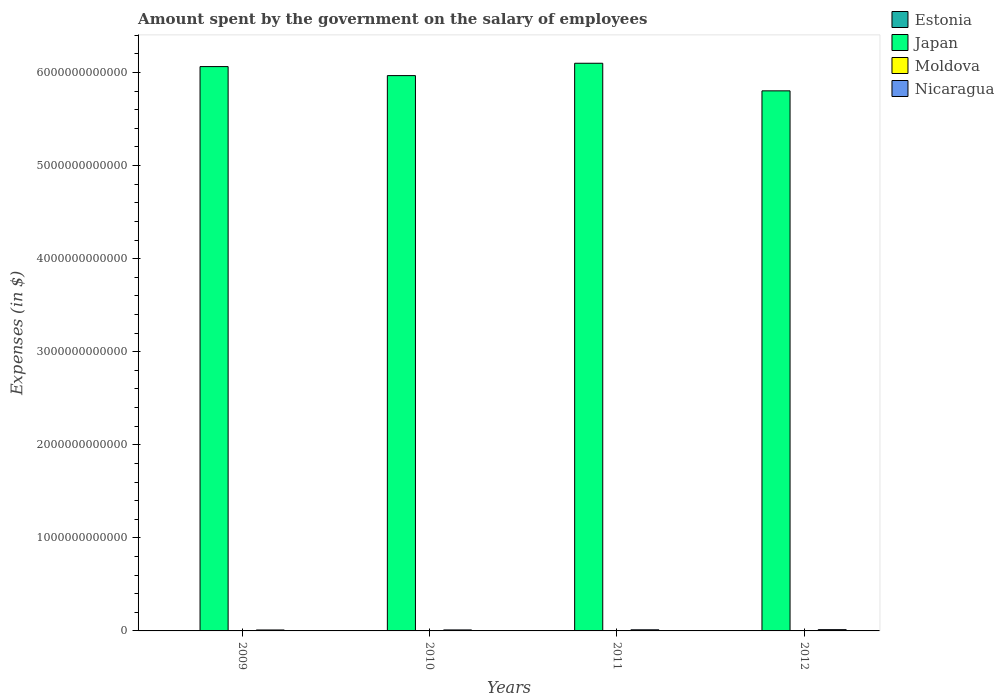How many different coloured bars are there?
Keep it short and to the point. 4. Are the number of bars on each tick of the X-axis equal?
Provide a short and direct response. Yes. How many bars are there on the 4th tick from the left?
Offer a very short reply. 4. How many bars are there on the 2nd tick from the right?
Provide a succinct answer. 4. What is the label of the 4th group of bars from the left?
Your answer should be very brief. 2012. In how many cases, is the number of bars for a given year not equal to the number of legend labels?
Keep it short and to the point. 0. What is the amount spent on the salary of employees by the government in Nicaragua in 2010?
Make the answer very short. 1.07e+1. Across all years, what is the maximum amount spent on the salary of employees by the government in Nicaragua?
Give a very brief answer. 1.36e+1. Across all years, what is the minimum amount spent on the salary of employees by the government in Nicaragua?
Give a very brief answer. 1.02e+1. What is the total amount spent on the salary of employees by the government in Nicaragua in the graph?
Your response must be concise. 4.64e+1. What is the difference between the amount spent on the salary of employees by the government in Japan in 2009 and that in 2010?
Provide a short and direct response. 9.68e+1. What is the difference between the amount spent on the salary of employees by the government in Estonia in 2010 and the amount spent on the salary of employees by the government in Nicaragua in 2009?
Offer a very short reply. -9.13e+09. What is the average amount spent on the salary of employees by the government in Estonia per year?
Provide a succinct answer. 1.09e+09. In the year 2009, what is the difference between the amount spent on the salary of employees by the government in Japan and amount spent on the salary of employees by the government in Estonia?
Provide a short and direct response. 6.06e+12. What is the ratio of the amount spent on the salary of employees by the government in Japan in 2009 to that in 2011?
Offer a terse response. 0.99. Is the amount spent on the salary of employees by the government in Estonia in 2011 less than that in 2012?
Give a very brief answer. Yes. What is the difference between the highest and the second highest amount spent on the salary of employees by the government in Japan?
Your answer should be very brief. 3.58e+1. What is the difference between the highest and the lowest amount spent on the salary of employees by the government in Moldova?
Your answer should be very brief. 4.85e+08. What does the 4th bar from the left in 2011 represents?
Make the answer very short. Nicaragua. How many years are there in the graph?
Your answer should be compact. 4. What is the difference between two consecutive major ticks on the Y-axis?
Your response must be concise. 1.00e+12. Does the graph contain any zero values?
Your answer should be very brief. No. How many legend labels are there?
Your response must be concise. 4. What is the title of the graph?
Provide a short and direct response. Amount spent by the government on the salary of employees. What is the label or title of the X-axis?
Offer a terse response. Years. What is the label or title of the Y-axis?
Offer a very short reply. Expenses (in $). What is the Expenses (in $) of Estonia in 2009?
Your response must be concise. 1.07e+09. What is the Expenses (in $) in Japan in 2009?
Provide a short and direct response. 6.06e+12. What is the Expenses (in $) of Moldova in 2009?
Your answer should be very brief. 3.47e+09. What is the Expenses (in $) of Nicaragua in 2009?
Offer a very short reply. 1.02e+1. What is the Expenses (in $) of Estonia in 2010?
Your answer should be very brief. 1.05e+09. What is the Expenses (in $) of Japan in 2010?
Give a very brief answer. 5.97e+12. What is the Expenses (in $) of Moldova in 2010?
Provide a succinct answer. 3.46e+09. What is the Expenses (in $) of Nicaragua in 2010?
Ensure brevity in your answer.  1.07e+1. What is the Expenses (in $) of Estonia in 2011?
Give a very brief answer. 1.09e+09. What is the Expenses (in $) in Japan in 2011?
Your answer should be very brief. 6.10e+12. What is the Expenses (in $) of Moldova in 2011?
Provide a short and direct response. 3.50e+09. What is the Expenses (in $) of Nicaragua in 2011?
Provide a short and direct response. 1.20e+1. What is the Expenses (in $) of Estonia in 2012?
Provide a short and direct response. 1.13e+09. What is the Expenses (in $) of Japan in 2012?
Your answer should be very brief. 5.80e+12. What is the Expenses (in $) in Moldova in 2012?
Offer a terse response. 3.94e+09. What is the Expenses (in $) in Nicaragua in 2012?
Offer a very short reply. 1.36e+1. Across all years, what is the maximum Expenses (in $) in Estonia?
Your answer should be compact. 1.13e+09. Across all years, what is the maximum Expenses (in $) of Japan?
Offer a very short reply. 6.10e+12. Across all years, what is the maximum Expenses (in $) of Moldova?
Give a very brief answer. 3.94e+09. Across all years, what is the maximum Expenses (in $) of Nicaragua?
Your answer should be compact. 1.36e+1. Across all years, what is the minimum Expenses (in $) in Estonia?
Ensure brevity in your answer.  1.05e+09. Across all years, what is the minimum Expenses (in $) of Japan?
Your answer should be very brief. 5.80e+12. Across all years, what is the minimum Expenses (in $) in Moldova?
Your answer should be very brief. 3.46e+09. Across all years, what is the minimum Expenses (in $) in Nicaragua?
Keep it short and to the point. 1.02e+1. What is the total Expenses (in $) in Estonia in the graph?
Ensure brevity in your answer.  4.34e+09. What is the total Expenses (in $) in Japan in the graph?
Offer a terse response. 2.39e+13. What is the total Expenses (in $) in Moldova in the graph?
Keep it short and to the point. 1.44e+1. What is the total Expenses (in $) in Nicaragua in the graph?
Your answer should be compact. 4.64e+1. What is the difference between the Expenses (in $) of Estonia in 2009 and that in 2010?
Ensure brevity in your answer.  2.65e+07. What is the difference between the Expenses (in $) in Japan in 2009 and that in 2010?
Keep it short and to the point. 9.68e+1. What is the difference between the Expenses (in $) of Moldova in 2009 and that in 2010?
Keep it short and to the point. 1.01e+07. What is the difference between the Expenses (in $) in Nicaragua in 2009 and that in 2010?
Your response must be concise. -4.83e+08. What is the difference between the Expenses (in $) of Estonia in 2009 and that in 2011?
Give a very brief answer. -1.71e+07. What is the difference between the Expenses (in $) of Japan in 2009 and that in 2011?
Provide a short and direct response. -3.58e+1. What is the difference between the Expenses (in $) in Moldova in 2009 and that in 2011?
Offer a very short reply. -3.28e+07. What is the difference between the Expenses (in $) in Nicaragua in 2009 and that in 2011?
Ensure brevity in your answer.  -1.78e+09. What is the difference between the Expenses (in $) of Estonia in 2009 and that in 2012?
Your answer should be compact. -6.31e+07. What is the difference between the Expenses (in $) in Japan in 2009 and that in 2012?
Your answer should be very brief. 2.61e+11. What is the difference between the Expenses (in $) of Moldova in 2009 and that in 2012?
Ensure brevity in your answer.  -4.75e+08. What is the difference between the Expenses (in $) in Nicaragua in 2009 and that in 2012?
Give a very brief answer. -3.45e+09. What is the difference between the Expenses (in $) in Estonia in 2010 and that in 2011?
Give a very brief answer. -4.36e+07. What is the difference between the Expenses (in $) of Japan in 2010 and that in 2011?
Ensure brevity in your answer.  -1.33e+11. What is the difference between the Expenses (in $) of Moldova in 2010 and that in 2011?
Provide a succinct answer. -4.29e+07. What is the difference between the Expenses (in $) in Nicaragua in 2010 and that in 2011?
Your answer should be very brief. -1.30e+09. What is the difference between the Expenses (in $) of Estonia in 2010 and that in 2012?
Ensure brevity in your answer.  -8.96e+07. What is the difference between the Expenses (in $) in Japan in 2010 and that in 2012?
Provide a short and direct response. 1.64e+11. What is the difference between the Expenses (in $) of Moldova in 2010 and that in 2012?
Offer a very short reply. -4.85e+08. What is the difference between the Expenses (in $) of Nicaragua in 2010 and that in 2012?
Offer a very short reply. -2.97e+09. What is the difference between the Expenses (in $) in Estonia in 2011 and that in 2012?
Your answer should be very brief. -4.60e+07. What is the difference between the Expenses (in $) of Japan in 2011 and that in 2012?
Your response must be concise. 2.96e+11. What is the difference between the Expenses (in $) of Moldova in 2011 and that in 2012?
Provide a succinct answer. -4.42e+08. What is the difference between the Expenses (in $) in Nicaragua in 2011 and that in 2012?
Make the answer very short. -1.67e+09. What is the difference between the Expenses (in $) in Estonia in 2009 and the Expenses (in $) in Japan in 2010?
Give a very brief answer. -5.97e+12. What is the difference between the Expenses (in $) of Estonia in 2009 and the Expenses (in $) of Moldova in 2010?
Your response must be concise. -2.39e+09. What is the difference between the Expenses (in $) of Estonia in 2009 and the Expenses (in $) of Nicaragua in 2010?
Offer a very short reply. -9.59e+09. What is the difference between the Expenses (in $) in Japan in 2009 and the Expenses (in $) in Moldova in 2010?
Offer a very short reply. 6.06e+12. What is the difference between the Expenses (in $) in Japan in 2009 and the Expenses (in $) in Nicaragua in 2010?
Provide a short and direct response. 6.05e+12. What is the difference between the Expenses (in $) of Moldova in 2009 and the Expenses (in $) of Nicaragua in 2010?
Your response must be concise. -7.19e+09. What is the difference between the Expenses (in $) of Estonia in 2009 and the Expenses (in $) of Japan in 2011?
Your response must be concise. -6.10e+12. What is the difference between the Expenses (in $) of Estonia in 2009 and the Expenses (in $) of Moldova in 2011?
Offer a very short reply. -2.43e+09. What is the difference between the Expenses (in $) of Estonia in 2009 and the Expenses (in $) of Nicaragua in 2011?
Make the answer very short. -1.09e+1. What is the difference between the Expenses (in $) in Japan in 2009 and the Expenses (in $) in Moldova in 2011?
Your answer should be very brief. 6.06e+12. What is the difference between the Expenses (in $) of Japan in 2009 and the Expenses (in $) of Nicaragua in 2011?
Your answer should be very brief. 6.05e+12. What is the difference between the Expenses (in $) of Moldova in 2009 and the Expenses (in $) of Nicaragua in 2011?
Provide a short and direct response. -8.49e+09. What is the difference between the Expenses (in $) in Estonia in 2009 and the Expenses (in $) in Japan in 2012?
Provide a short and direct response. -5.80e+12. What is the difference between the Expenses (in $) of Estonia in 2009 and the Expenses (in $) of Moldova in 2012?
Offer a terse response. -2.87e+09. What is the difference between the Expenses (in $) in Estonia in 2009 and the Expenses (in $) in Nicaragua in 2012?
Keep it short and to the point. -1.26e+1. What is the difference between the Expenses (in $) in Japan in 2009 and the Expenses (in $) in Moldova in 2012?
Offer a terse response. 6.06e+12. What is the difference between the Expenses (in $) in Japan in 2009 and the Expenses (in $) in Nicaragua in 2012?
Your response must be concise. 6.05e+12. What is the difference between the Expenses (in $) of Moldova in 2009 and the Expenses (in $) of Nicaragua in 2012?
Your response must be concise. -1.02e+1. What is the difference between the Expenses (in $) in Estonia in 2010 and the Expenses (in $) in Japan in 2011?
Provide a short and direct response. -6.10e+12. What is the difference between the Expenses (in $) in Estonia in 2010 and the Expenses (in $) in Moldova in 2011?
Make the answer very short. -2.46e+09. What is the difference between the Expenses (in $) of Estonia in 2010 and the Expenses (in $) of Nicaragua in 2011?
Offer a very short reply. -1.09e+1. What is the difference between the Expenses (in $) of Japan in 2010 and the Expenses (in $) of Moldova in 2011?
Keep it short and to the point. 5.96e+12. What is the difference between the Expenses (in $) of Japan in 2010 and the Expenses (in $) of Nicaragua in 2011?
Give a very brief answer. 5.96e+12. What is the difference between the Expenses (in $) of Moldova in 2010 and the Expenses (in $) of Nicaragua in 2011?
Ensure brevity in your answer.  -8.50e+09. What is the difference between the Expenses (in $) of Estonia in 2010 and the Expenses (in $) of Japan in 2012?
Your answer should be very brief. -5.80e+12. What is the difference between the Expenses (in $) in Estonia in 2010 and the Expenses (in $) in Moldova in 2012?
Your response must be concise. -2.90e+09. What is the difference between the Expenses (in $) in Estonia in 2010 and the Expenses (in $) in Nicaragua in 2012?
Your response must be concise. -1.26e+1. What is the difference between the Expenses (in $) of Japan in 2010 and the Expenses (in $) of Moldova in 2012?
Make the answer very short. 5.96e+12. What is the difference between the Expenses (in $) in Japan in 2010 and the Expenses (in $) in Nicaragua in 2012?
Your response must be concise. 5.95e+12. What is the difference between the Expenses (in $) in Moldova in 2010 and the Expenses (in $) in Nicaragua in 2012?
Offer a terse response. -1.02e+1. What is the difference between the Expenses (in $) in Estonia in 2011 and the Expenses (in $) in Japan in 2012?
Make the answer very short. -5.80e+12. What is the difference between the Expenses (in $) of Estonia in 2011 and the Expenses (in $) of Moldova in 2012?
Keep it short and to the point. -2.85e+09. What is the difference between the Expenses (in $) in Estonia in 2011 and the Expenses (in $) in Nicaragua in 2012?
Provide a succinct answer. -1.25e+1. What is the difference between the Expenses (in $) in Japan in 2011 and the Expenses (in $) in Moldova in 2012?
Give a very brief answer. 6.10e+12. What is the difference between the Expenses (in $) in Japan in 2011 and the Expenses (in $) in Nicaragua in 2012?
Provide a short and direct response. 6.09e+12. What is the difference between the Expenses (in $) of Moldova in 2011 and the Expenses (in $) of Nicaragua in 2012?
Keep it short and to the point. -1.01e+1. What is the average Expenses (in $) in Estonia per year?
Provide a succinct answer. 1.09e+09. What is the average Expenses (in $) of Japan per year?
Offer a very short reply. 5.98e+12. What is the average Expenses (in $) of Moldova per year?
Offer a terse response. 3.59e+09. What is the average Expenses (in $) in Nicaragua per year?
Make the answer very short. 1.16e+1. In the year 2009, what is the difference between the Expenses (in $) of Estonia and Expenses (in $) of Japan?
Keep it short and to the point. -6.06e+12. In the year 2009, what is the difference between the Expenses (in $) in Estonia and Expenses (in $) in Moldova?
Ensure brevity in your answer.  -2.40e+09. In the year 2009, what is the difference between the Expenses (in $) in Estonia and Expenses (in $) in Nicaragua?
Your answer should be compact. -9.11e+09. In the year 2009, what is the difference between the Expenses (in $) in Japan and Expenses (in $) in Moldova?
Make the answer very short. 6.06e+12. In the year 2009, what is the difference between the Expenses (in $) in Japan and Expenses (in $) in Nicaragua?
Offer a very short reply. 6.05e+12. In the year 2009, what is the difference between the Expenses (in $) of Moldova and Expenses (in $) of Nicaragua?
Your answer should be compact. -6.71e+09. In the year 2010, what is the difference between the Expenses (in $) in Estonia and Expenses (in $) in Japan?
Offer a very short reply. -5.97e+12. In the year 2010, what is the difference between the Expenses (in $) in Estonia and Expenses (in $) in Moldova?
Offer a terse response. -2.41e+09. In the year 2010, what is the difference between the Expenses (in $) of Estonia and Expenses (in $) of Nicaragua?
Give a very brief answer. -9.62e+09. In the year 2010, what is the difference between the Expenses (in $) of Japan and Expenses (in $) of Moldova?
Your response must be concise. 5.96e+12. In the year 2010, what is the difference between the Expenses (in $) of Japan and Expenses (in $) of Nicaragua?
Your answer should be very brief. 5.96e+12. In the year 2010, what is the difference between the Expenses (in $) in Moldova and Expenses (in $) in Nicaragua?
Offer a very short reply. -7.20e+09. In the year 2011, what is the difference between the Expenses (in $) of Estonia and Expenses (in $) of Japan?
Offer a very short reply. -6.10e+12. In the year 2011, what is the difference between the Expenses (in $) in Estonia and Expenses (in $) in Moldova?
Your response must be concise. -2.41e+09. In the year 2011, what is the difference between the Expenses (in $) in Estonia and Expenses (in $) in Nicaragua?
Ensure brevity in your answer.  -1.09e+1. In the year 2011, what is the difference between the Expenses (in $) of Japan and Expenses (in $) of Moldova?
Keep it short and to the point. 6.10e+12. In the year 2011, what is the difference between the Expenses (in $) in Japan and Expenses (in $) in Nicaragua?
Provide a short and direct response. 6.09e+12. In the year 2011, what is the difference between the Expenses (in $) of Moldova and Expenses (in $) of Nicaragua?
Make the answer very short. -8.46e+09. In the year 2012, what is the difference between the Expenses (in $) in Estonia and Expenses (in $) in Japan?
Give a very brief answer. -5.80e+12. In the year 2012, what is the difference between the Expenses (in $) of Estonia and Expenses (in $) of Moldova?
Provide a short and direct response. -2.81e+09. In the year 2012, what is the difference between the Expenses (in $) of Estonia and Expenses (in $) of Nicaragua?
Your answer should be compact. -1.25e+1. In the year 2012, what is the difference between the Expenses (in $) in Japan and Expenses (in $) in Moldova?
Make the answer very short. 5.80e+12. In the year 2012, what is the difference between the Expenses (in $) in Japan and Expenses (in $) in Nicaragua?
Give a very brief answer. 5.79e+12. In the year 2012, what is the difference between the Expenses (in $) in Moldova and Expenses (in $) in Nicaragua?
Ensure brevity in your answer.  -9.69e+09. What is the ratio of the Expenses (in $) in Estonia in 2009 to that in 2010?
Offer a very short reply. 1.03. What is the ratio of the Expenses (in $) in Japan in 2009 to that in 2010?
Give a very brief answer. 1.02. What is the ratio of the Expenses (in $) in Nicaragua in 2009 to that in 2010?
Provide a succinct answer. 0.95. What is the ratio of the Expenses (in $) in Estonia in 2009 to that in 2011?
Offer a terse response. 0.98. What is the ratio of the Expenses (in $) of Japan in 2009 to that in 2011?
Keep it short and to the point. 0.99. What is the ratio of the Expenses (in $) in Moldova in 2009 to that in 2011?
Your answer should be compact. 0.99. What is the ratio of the Expenses (in $) in Nicaragua in 2009 to that in 2011?
Make the answer very short. 0.85. What is the ratio of the Expenses (in $) of Japan in 2009 to that in 2012?
Provide a succinct answer. 1.04. What is the ratio of the Expenses (in $) in Moldova in 2009 to that in 2012?
Your answer should be very brief. 0.88. What is the ratio of the Expenses (in $) of Nicaragua in 2009 to that in 2012?
Ensure brevity in your answer.  0.75. What is the ratio of the Expenses (in $) of Estonia in 2010 to that in 2011?
Ensure brevity in your answer.  0.96. What is the ratio of the Expenses (in $) in Japan in 2010 to that in 2011?
Make the answer very short. 0.98. What is the ratio of the Expenses (in $) of Moldova in 2010 to that in 2011?
Provide a short and direct response. 0.99. What is the ratio of the Expenses (in $) of Nicaragua in 2010 to that in 2011?
Offer a terse response. 0.89. What is the ratio of the Expenses (in $) in Estonia in 2010 to that in 2012?
Give a very brief answer. 0.92. What is the ratio of the Expenses (in $) of Japan in 2010 to that in 2012?
Offer a terse response. 1.03. What is the ratio of the Expenses (in $) in Moldova in 2010 to that in 2012?
Your answer should be compact. 0.88. What is the ratio of the Expenses (in $) in Nicaragua in 2010 to that in 2012?
Your response must be concise. 0.78. What is the ratio of the Expenses (in $) in Estonia in 2011 to that in 2012?
Your response must be concise. 0.96. What is the ratio of the Expenses (in $) of Japan in 2011 to that in 2012?
Offer a very short reply. 1.05. What is the ratio of the Expenses (in $) of Moldova in 2011 to that in 2012?
Provide a succinct answer. 0.89. What is the ratio of the Expenses (in $) in Nicaragua in 2011 to that in 2012?
Keep it short and to the point. 0.88. What is the difference between the highest and the second highest Expenses (in $) of Estonia?
Ensure brevity in your answer.  4.60e+07. What is the difference between the highest and the second highest Expenses (in $) in Japan?
Make the answer very short. 3.58e+1. What is the difference between the highest and the second highest Expenses (in $) of Moldova?
Offer a very short reply. 4.42e+08. What is the difference between the highest and the second highest Expenses (in $) in Nicaragua?
Offer a very short reply. 1.67e+09. What is the difference between the highest and the lowest Expenses (in $) in Estonia?
Offer a terse response. 8.96e+07. What is the difference between the highest and the lowest Expenses (in $) of Japan?
Your answer should be compact. 2.96e+11. What is the difference between the highest and the lowest Expenses (in $) of Moldova?
Your answer should be compact. 4.85e+08. What is the difference between the highest and the lowest Expenses (in $) of Nicaragua?
Make the answer very short. 3.45e+09. 